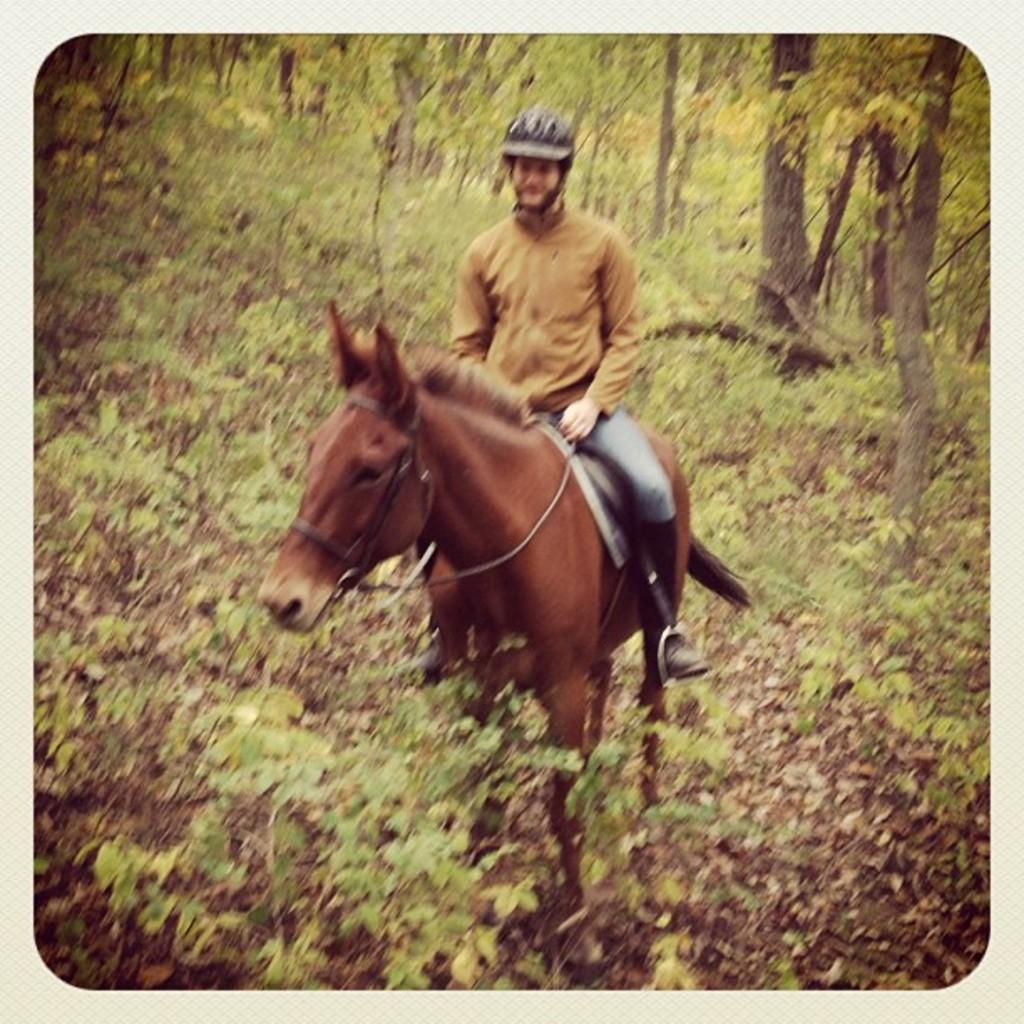What is the main subject of the image? There is a man in the image. What is the man doing in the image? The man is riding a horse. What can be seen in the background of the image? There are trees visible in the image. Where can the books be found in the image? There are no books present in the image. What type of drain is visible in the image? There is no drain present in the image. 